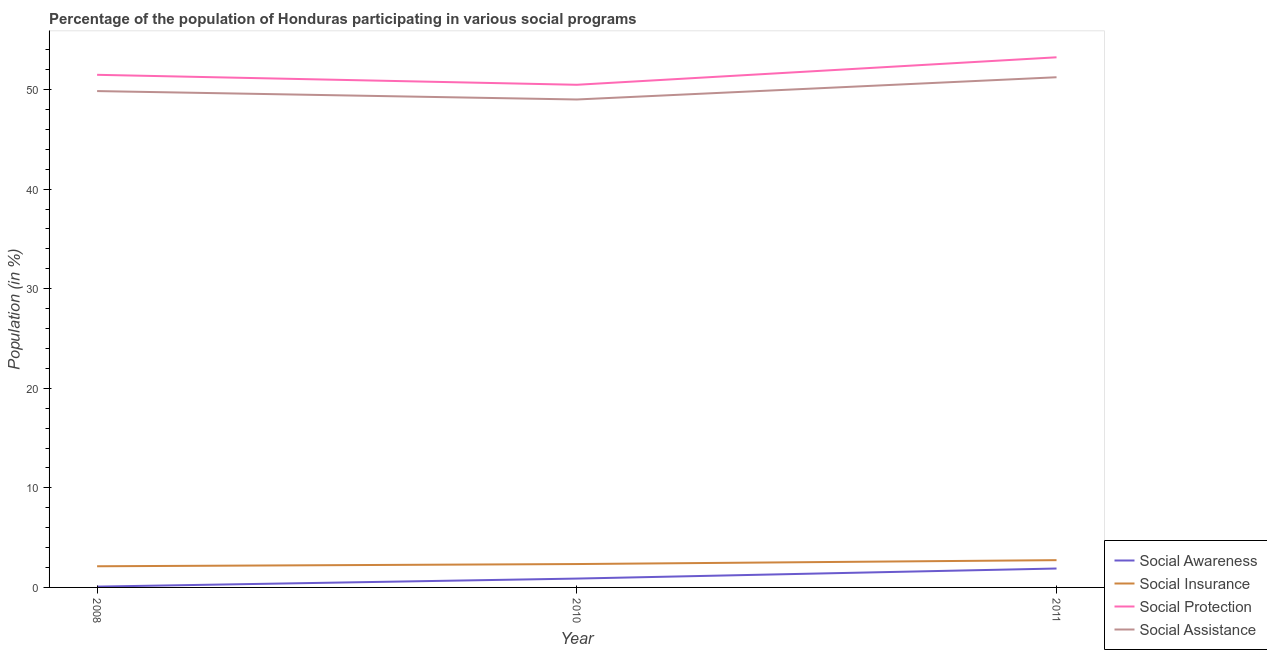How many different coloured lines are there?
Keep it short and to the point. 4. Does the line corresponding to participation of population in social awareness programs intersect with the line corresponding to participation of population in social assistance programs?
Keep it short and to the point. No. What is the participation of population in social awareness programs in 2008?
Offer a very short reply. 0.08. Across all years, what is the maximum participation of population in social insurance programs?
Provide a succinct answer. 2.74. Across all years, what is the minimum participation of population in social awareness programs?
Give a very brief answer. 0.08. In which year was the participation of population in social insurance programs maximum?
Provide a succinct answer. 2011. What is the total participation of population in social assistance programs in the graph?
Your answer should be compact. 150.09. What is the difference between the participation of population in social insurance programs in 2010 and that in 2011?
Offer a very short reply. -0.39. What is the difference between the participation of population in social assistance programs in 2011 and the participation of population in social awareness programs in 2008?
Your answer should be very brief. 51.16. What is the average participation of population in social awareness programs per year?
Give a very brief answer. 0.96. In the year 2011, what is the difference between the participation of population in social assistance programs and participation of population in social protection programs?
Your answer should be compact. -2. In how many years, is the participation of population in social insurance programs greater than 4 %?
Your answer should be very brief. 0. What is the ratio of the participation of population in social assistance programs in 2010 to that in 2011?
Your answer should be very brief. 0.96. Is the participation of population in social insurance programs in 2008 less than that in 2010?
Your answer should be compact. Yes. What is the difference between the highest and the second highest participation of population in social protection programs?
Provide a succinct answer. 1.76. What is the difference between the highest and the lowest participation of population in social assistance programs?
Offer a terse response. 2.23. Is the sum of the participation of population in social assistance programs in 2010 and 2011 greater than the maximum participation of population in social awareness programs across all years?
Offer a very short reply. Yes. Is it the case that in every year, the sum of the participation of population in social assistance programs and participation of population in social protection programs is greater than the sum of participation of population in social insurance programs and participation of population in social awareness programs?
Provide a short and direct response. No. Does the participation of population in social assistance programs monotonically increase over the years?
Keep it short and to the point. No. Is the participation of population in social protection programs strictly greater than the participation of population in social insurance programs over the years?
Your response must be concise. Yes. How many lines are there?
Offer a terse response. 4. What is the difference between two consecutive major ticks on the Y-axis?
Your answer should be very brief. 10. Does the graph contain grids?
Make the answer very short. No. Where does the legend appear in the graph?
Provide a short and direct response. Bottom right. How are the legend labels stacked?
Provide a short and direct response. Vertical. What is the title of the graph?
Your answer should be compact. Percentage of the population of Honduras participating in various social programs . Does "Others" appear as one of the legend labels in the graph?
Keep it short and to the point. No. What is the label or title of the X-axis?
Offer a terse response. Year. What is the Population (in %) of Social Awareness in 2008?
Your answer should be very brief. 0.08. What is the Population (in %) in Social Insurance in 2008?
Keep it short and to the point. 2.12. What is the Population (in %) in Social Protection in 2008?
Your answer should be very brief. 51.48. What is the Population (in %) in Social Assistance in 2008?
Offer a very short reply. 49.85. What is the Population (in %) in Social Awareness in 2010?
Offer a terse response. 0.89. What is the Population (in %) in Social Insurance in 2010?
Offer a terse response. 2.35. What is the Population (in %) of Social Protection in 2010?
Provide a short and direct response. 50.48. What is the Population (in %) in Social Assistance in 2010?
Make the answer very short. 49. What is the Population (in %) of Social Awareness in 2011?
Offer a terse response. 1.9. What is the Population (in %) in Social Insurance in 2011?
Provide a succinct answer. 2.74. What is the Population (in %) in Social Protection in 2011?
Your answer should be very brief. 53.24. What is the Population (in %) in Social Assistance in 2011?
Ensure brevity in your answer.  51.24. Across all years, what is the maximum Population (in %) in Social Awareness?
Your answer should be compact. 1.9. Across all years, what is the maximum Population (in %) of Social Insurance?
Make the answer very short. 2.74. Across all years, what is the maximum Population (in %) in Social Protection?
Offer a terse response. 53.24. Across all years, what is the maximum Population (in %) of Social Assistance?
Your answer should be compact. 51.24. Across all years, what is the minimum Population (in %) of Social Awareness?
Give a very brief answer. 0.08. Across all years, what is the minimum Population (in %) in Social Insurance?
Your response must be concise. 2.12. Across all years, what is the minimum Population (in %) of Social Protection?
Give a very brief answer. 50.48. Across all years, what is the minimum Population (in %) of Social Assistance?
Keep it short and to the point. 49. What is the total Population (in %) in Social Awareness in the graph?
Provide a short and direct response. 2.87. What is the total Population (in %) in Social Insurance in the graph?
Make the answer very short. 7.21. What is the total Population (in %) in Social Protection in the graph?
Your answer should be compact. 155.21. What is the total Population (in %) of Social Assistance in the graph?
Your response must be concise. 150.09. What is the difference between the Population (in %) of Social Awareness in 2008 and that in 2010?
Offer a very short reply. -0.81. What is the difference between the Population (in %) in Social Insurance in 2008 and that in 2010?
Keep it short and to the point. -0.22. What is the difference between the Population (in %) in Social Protection in 2008 and that in 2010?
Give a very brief answer. 1. What is the difference between the Population (in %) of Social Assistance in 2008 and that in 2010?
Give a very brief answer. 0.84. What is the difference between the Population (in %) in Social Awareness in 2008 and that in 2011?
Provide a short and direct response. -1.82. What is the difference between the Population (in %) in Social Insurance in 2008 and that in 2011?
Offer a terse response. -0.61. What is the difference between the Population (in %) of Social Protection in 2008 and that in 2011?
Make the answer very short. -1.76. What is the difference between the Population (in %) of Social Assistance in 2008 and that in 2011?
Provide a succinct answer. -1.39. What is the difference between the Population (in %) of Social Awareness in 2010 and that in 2011?
Make the answer very short. -1.01. What is the difference between the Population (in %) in Social Insurance in 2010 and that in 2011?
Keep it short and to the point. -0.39. What is the difference between the Population (in %) of Social Protection in 2010 and that in 2011?
Offer a terse response. -2.76. What is the difference between the Population (in %) of Social Assistance in 2010 and that in 2011?
Keep it short and to the point. -2.23. What is the difference between the Population (in %) in Social Awareness in 2008 and the Population (in %) in Social Insurance in 2010?
Your answer should be compact. -2.27. What is the difference between the Population (in %) of Social Awareness in 2008 and the Population (in %) of Social Protection in 2010?
Provide a succinct answer. -50.4. What is the difference between the Population (in %) of Social Awareness in 2008 and the Population (in %) of Social Assistance in 2010?
Your response must be concise. -48.92. What is the difference between the Population (in %) of Social Insurance in 2008 and the Population (in %) of Social Protection in 2010?
Provide a succinct answer. -48.36. What is the difference between the Population (in %) in Social Insurance in 2008 and the Population (in %) in Social Assistance in 2010?
Make the answer very short. -46.88. What is the difference between the Population (in %) of Social Protection in 2008 and the Population (in %) of Social Assistance in 2010?
Give a very brief answer. 2.48. What is the difference between the Population (in %) in Social Awareness in 2008 and the Population (in %) in Social Insurance in 2011?
Give a very brief answer. -2.66. What is the difference between the Population (in %) of Social Awareness in 2008 and the Population (in %) of Social Protection in 2011?
Your answer should be compact. -53.16. What is the difference between the Population (in %) of Social Awareness in 2008 and the Population (in %) of Social Assistance in 2011?
Your answer should be compact. -51.16. What is the difference between the Population (in %) of Social Insurance in 2008 and the Population (in %) of Social Protection in 2011?
Offer a very short reply. -51.12. What is the difference between the Population (in %) of Social Insurance in 2008 and the Population (in %) of Social Assistance in 2011?
Give a very brief answer. -49.11. What is the difference between the Population (in %) of Social Protection in 2008 and the Population (in %) of Social Assistance in 2011?
Keep it short and to the point. 0.24. What is the difference between the Population (in %) of Social Awareness in 2010 and the Population (in %) of Social Insurance in 2011?
Make the answer very short. -1.85. What is the difference between the Population (in %) in Social Awareness in 2010 and the Population (in %) in Social Protection in 2011?
Your response must be concise. -52.35. What is the difference between the Population (in %) in Social Awareness in 2010 and the Population (in %) in Social Assistance in 2011?
Give a very brief answer. -50.35. What is the difference between the Population (in %) in Social Insurance in 2010 and the Population (in %) in Social Protection in 2011?
Your answer should be compact. -50.89. What is the difference between the Population (in %) in Social Insurance in 2010 and the Population (in %) in Social Assistance in 2011?
Offer a very short reply. -48.89. What is the difference between the Population (in %) of Social Protection in 2010 and the Population (in %) of Social Assistance in 2011?
Offer a terse response. -0.76. What is the average Population (in %) of Social Awareness per year?
Keep it short and to the point. 0.96. What is the average Population (in %) in Social Insurance per year?
Your response must be concise. 2.4. What is the average Population (in %) in Social Protection per year?
Your answer should be very brief. 51.74. What is the average Population (in %) of Social Assistance per year?
Keep it short and to the point. 50.03. In the year 2008, what is the difference between the Population (in %) in Social Awareness and Population (in %) in Social Insurance?
Give a very brief answer. -2.04. In the year 2008, what is the difference between the Population (in %) of Social Awareness and Population (in %) of Social Protection?
Make the answer very short. -51.4. In the year 2008, what is the difference between the Population (in %) in Social Awareness and Population (in %) in Social Assistance?
Offer a terse response. -49.77. In the year 2008, what is the difference between the Population (in %) in Social Insurance and Population (in %) in Social Protection?
Ensure brevity in your answer.  -49.36. In the year 2008, what is the difference between the Population (in %) in Social Insurance and Population (in %) in Social Assistance?
Offer a terse response. -47.72. In the year 2008, what is the difference between the Population (in %) of Social Protection and Population (in %) of Social Assistance?
Your answer should be very brief. 1.63. In the year 2010, what is the difference between the Population (in %) of Social Awareness and Population (in %) of Social Insurance?
Keep it short and to the point. -1.46. In the year 2010, what is the difference between the Population (in %) of Social Awareness and Population (in %) of Social Protection?
Provide a short and direct response. -49.59. In the year 2010, what is the difference between the Population (in %) in Social Awareness and Population (in %) in Social Assistance?
Make the answer very short. -48.12. In the year 2010, what is the difference between the Population (in %) in Social Insurance and Population (in %) in Social Protection?
Your answer should be very brief. -48.13. In the year 2010, what is the difference between the Population (in %) of Social Insurance and Population (in %) of Social Assistance?
Your answer should be very brief. -46.66. In the year 2010, what is the difference between the Population (in %) of Social Protection and Population (in %) of Social Assistance?
Ensure brevity in your answer.  1.48. In the year 2011, what is the difference between the Population (in %) in Social Awareness and Population (in %) in Social Insurance?
Your answer should be very brief. -0.84. In the year 2011, what is the difference between the Population (in %) of Social Awareness and Population (in %) of Social Protection?
Your answer should be compact. -51.34. In the year 2011, what is the difference between the Population (in %) in Social Awareness and Population (in %) in Social Assistance?
Your answer should be very brief. -49.34. In the year 2011, what is the difference between the Population (in %) in Social Insurance and Population (in %) in Social Protection?
Offer a terse response. -50.5. In the year 2011, what is the difference between the Population (in %) in Social Insurance and Population (in %) in Social Assistance?
Keep it short and to the point. -48.5. In the year 2011, what is the difference between the Population (in %) in Social Protection and Population (in %) in Social Assistance?
Keep it short and to the point. 2. What is the ratio of the Population (in %) in Social Awareness in 2008 to that in 2010?
Your response must be concise. 0.09. What is the ratio of the Population (in %) in Social Insurance in 2008 to that in 2010?
Give a very brief answer. 0.9. What is the ratio of the Population (in %) of Social Protection in 2008 to that in 2010?
Make the answer very short. 1.02. What is the ratio of the Population (in %) in Social Assistance in 2008 to that in 2010?
Provide a short and direct response. 1.02. What is the ratio of the Population (in %) of Social Awareness in 2008 to that in 2011?
Provide a short and direct response. 0.04. What is the ratio of the Population (in %) of Social Insurance in 2008 to that in 2011?
Your response must be concise. 0.78. What is the ratio of the Population (in %) of Social Protection in 2008 to that in 2011?
Provide a succinct answer. 0.97. What is the ratio of the Population (in %) in Social Assistance in 2008 to that in 2011?
Your answer should be compact. 0.97. What is the ratio of the Population (in %) in Social Awareness in 2010 to that in 2011?
Your response must be concise. 0.47. What is the ratio of the Population (in %) of Social Insurance in 2010 to that in 2011?
Provide a succinct answer. 0.86. What is the ratio of the Population (in %) in Social Protection in 2010 to that in 2011?
Provide a short and direct response. 0.95. What is the ratio of the Population (in %) of Social Assistance in 2010 to that in 2011?
Your answer should be compact. 0.96. What is the difference between the highest and the second highest Population (in %) in Social Awareness?
Give a very brief answer. 1.01. What is the difference between the highest and the second highest Population (in %) of Social Insurance?
Offer a terse response. 0.39. What is the difference between the highest and the second highest Population (in %) of Social Protection?
Keep it short and to the point. 1.76. What is the difference between the highest and the second highest Population (in %) in Social Assistance?
Keep it short and to the point. 1.39. What is the difference between the highest and the lowest Population (in %) in Social Awareness?
Provide a succinct answer. 1.82. What is the difference between the highest and the lowest Population (in %) of Social Insurance?
Your answer should be compact. 0.61. What is the difference between the highest and the lowest Population (in %) of Social Protection?
Provide a short and direct response. 2.76. What is the difference between the highest and the lowest Population (in %) of Social Assistance?
Ensure brevity in your answer.  2.23. 